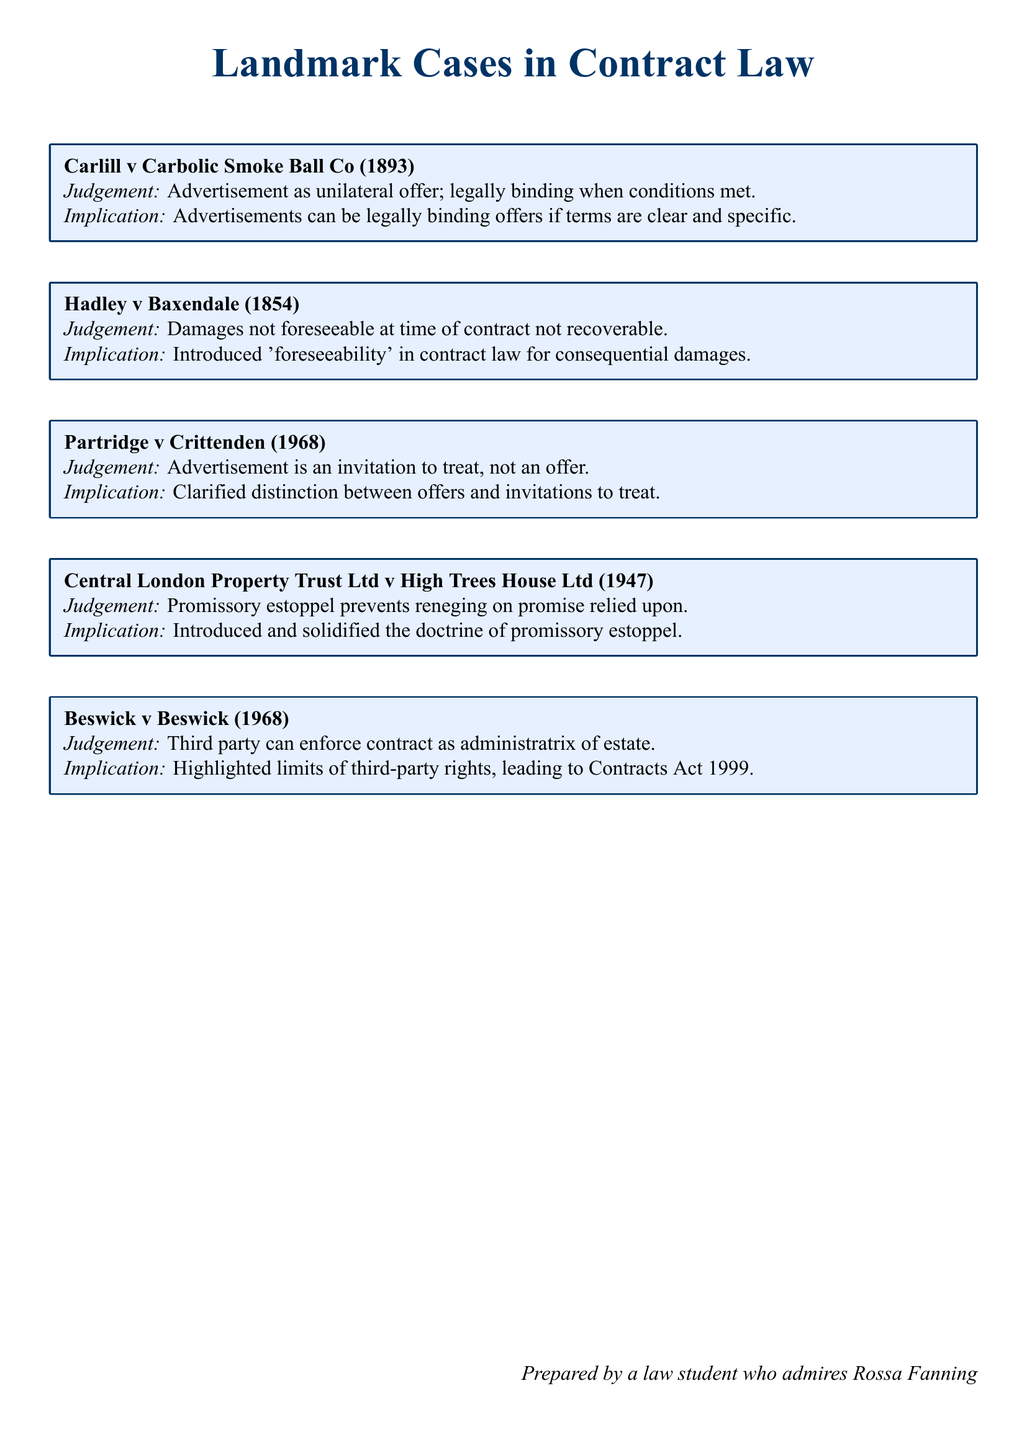What is the case name associated with unilateral offers? The case name is the first listed case that discusses unilateral offers in advertisements.
Answer: Carlill v Carbolic Smoke Ball Co What year was Hadley v Baxendale decided? The decision date of the case Hadley v Baxendale is mentioned in the document.
Answer: 1854 What legal principle was introduced by Hadley v Baxendale? The principle is discussed in relation to the recoverability of damages in contracts, specifically focusing on foreseeability.
Answer: 'foreseeability' What does the judgement in Partridge v Crittenden clarify? The judgement explains a key distinction regarding advertisements in contract law, indicating their nature.
Answer: distinction between offers and invitations to treat Which legal doctrine was solidified by Central London Property Trust Ltd v High Trees House Ltd? The document specifies which doctrine was introduced and solidified by this case.
Answer: doctrine of promissory estoppel What role can a third party play as determined in Beswick v Beswick? The case describes the specific role that allows a third party to enforce a contract under certain conditions.
Answer: administratrix of estate What is the implication of the judgement in Carlill v Carbolic Smoke Ball Co? The judgement's implication is detailed and focuses on the nature of clear and specific offers.
Answer: Advertisements can be legally binding offers if terms are clear and specific What significant act was influenced by the judgement in Beswick v Beswick? The document mentions an act that was a result of the insights gained from this case.
Answer: Contracts Act 1999 